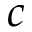<formula> <loc_0><loc_0><loc_500><loc_500>c</formula> 